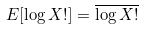Convert formula to latex. <formula><loc_0><loc_0><loc_500><loc_500>E [ \log X ! ] = \overline { \log X ! }</formula> 